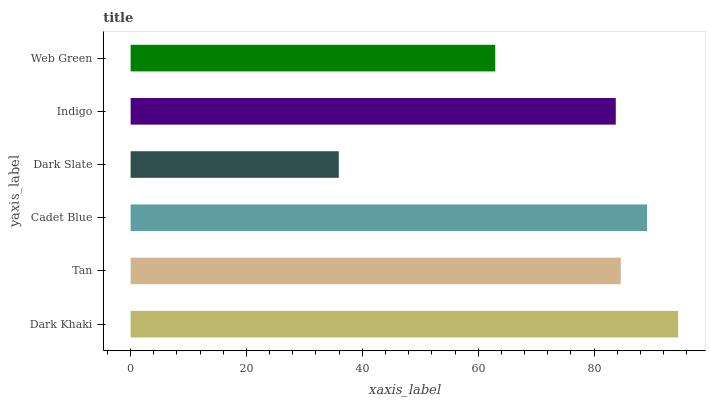Is Dark Slate the minimum?
Answer yes or no. Yes. Is Dark Khaki the maximum?
Answer yes or no. Yes. Is Tan the minimum?
Answer yes or no. No. Is Tan the maximum?
Answer yes or no. No. Is Dark Khaki greater than Tan?
Answer yes or no. Yes. Is Tan less than Dark Khaki?
Answer yes or no. Yes. Is Tan greater than Dark Khaki?
Answer yes or no. No. Is Dark Khaki less than Tan?
Answer yes or no. No. Is Tan the high median?
Answer yes or no. Yes. Is Indigo the low median?
Answer yes or no. Yes. Is Dark Slate the high median?
Answer yes or no. No. Is Dark Khaki the low median?
Answer yes or no. No. 